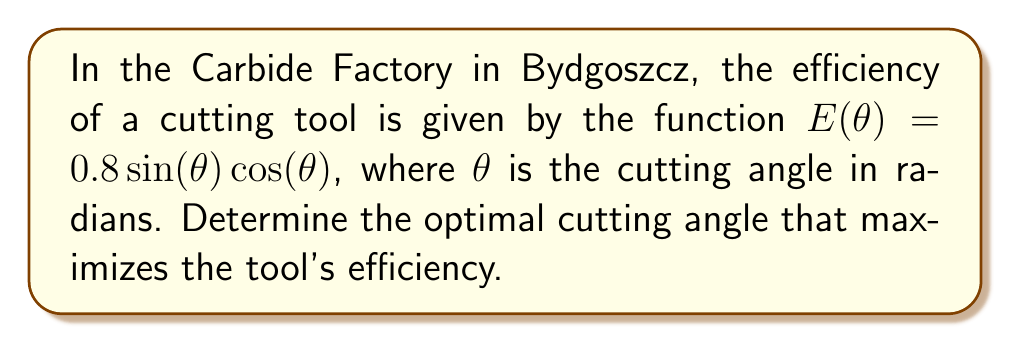Give your solution to this math problem. To find the optimal cutting angle, we need to maximize the efficiency function $E(\theta)$. This can be done by finding where the derivative of $E(\theta)$ equals zero.

Step 1: Calculate the derivative of $E(\theta)$
$$\begin{align}
E(\theta) &= 0.8\sin(\theta)\cos(\theta) \\
E'(\theta) &= 0.8[\sin(\theta)(-\sin(\theta)) + \cos(\theta)\cos(\theta)] \\
&= 0.8[\cos^2(\theta) - \sin^2(\theta)] \\
&= 0.8\cos(2\theta)
\end{align}$$

Step 2: Set the derivative equal to zero and solve
$$\begin{align}
0.8\cos(2\theta) &= 0 \\
\cos(2\theta) &= 0 \\
2\theta &= \frac{\pi}{2} + \pi n, \quad n \in \mathbb{Z} \\
\theta &= \frac{\pi}{4} + \frac{\pi n}{2}, \quad n \in \mathbb{Z}
\end{align}$$

Step 3: Determine which solution maximizes $E(\theta)$
The solution $\theta = \frac{\pi}{4}$ (when $n = 0$) gives a maximum, as $E''(\frac{\pi}{4}) < 0$.

Step 4: Convert radians to degrees
$$\frac{\pi}{4} \text{ radians} = 45^\circ$$
Answer: $45^\circ$ 